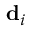Convert formula to latex. <formula><loc_0><loc_0><loc_500><loc_500>{ d } _ { i }</formula> 